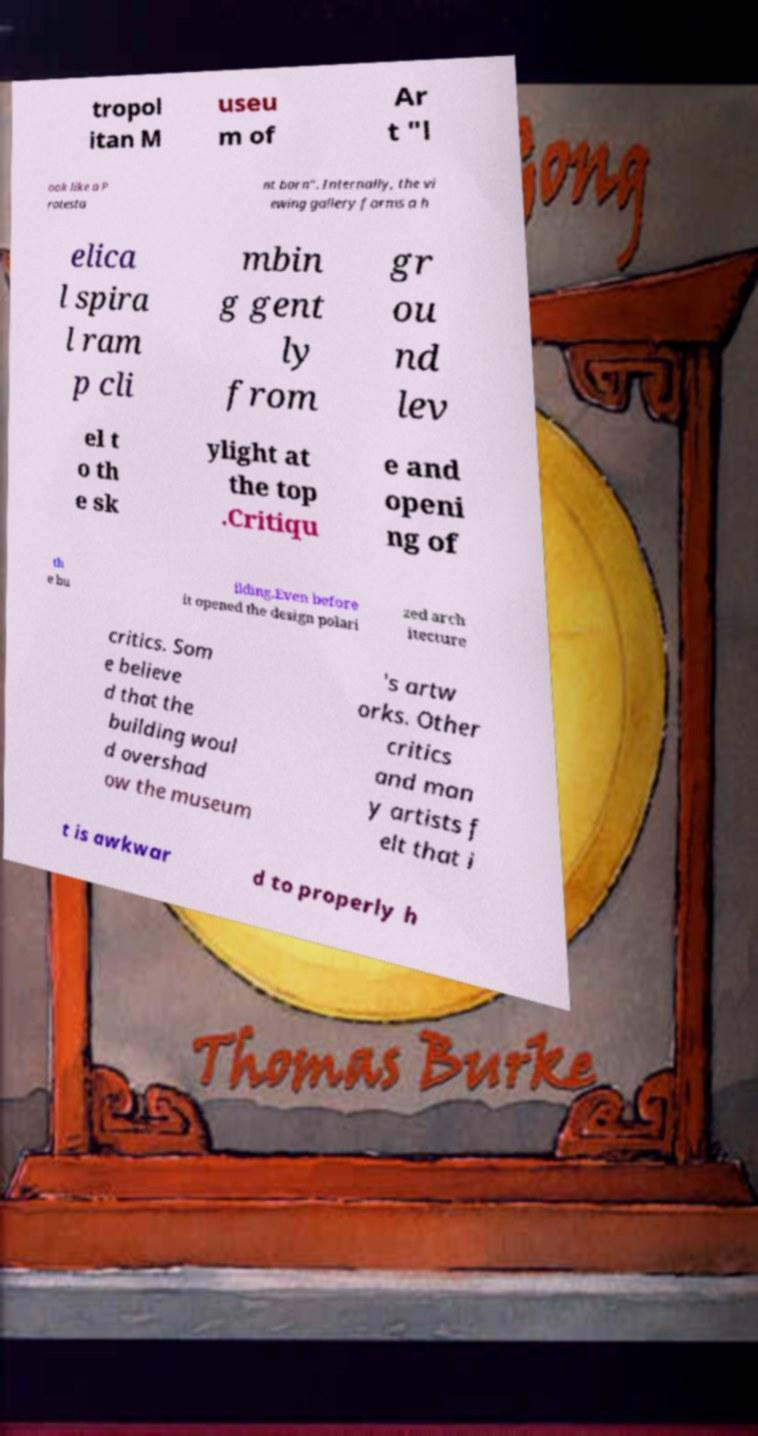Could you extract and type out the text from this image? tropol itan M useu m of Ar t "l ook like a P rotesta nt barn". Internally, the vi ewing gallery forms a h elica l spira l ram p cli mbin g gent ly from gr ou nd lev el t o th e sk ylight at the top .Critiqu e and openi ng of th e bu ilding.Even before it opened the design polari zed arch itecture critics. Som e believe d that the building woul d overshad ow the museum 's artw orks. Other critics and man y artists f elt that i t is awkwar d to properly h 